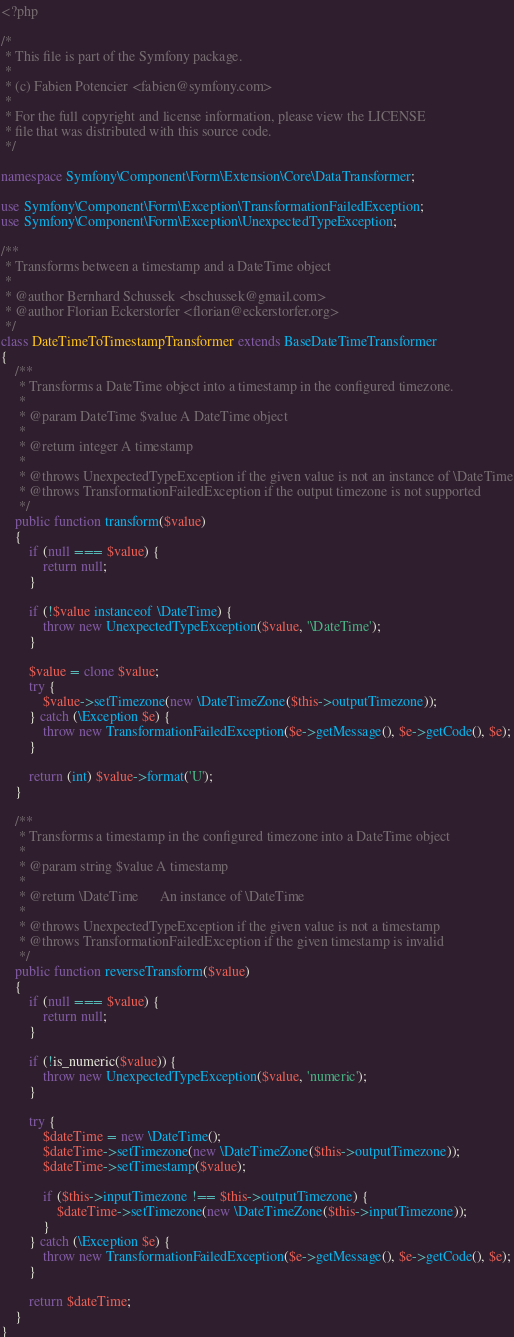Convert code to text. <code><loc_0><loc_0><loc_500><loc_500><_PHP_><?php

/*
 * This file is part of the Symfony package.
 *
 * (c) Fabien Potencier <fabien@symfony.com>
 *
 * For the full copyright and license information, please view the LICENSE
 * file that was distributed with this source code.
 */

namespace Symfony\Component\Form\Extension\Core\DataTransformer;

use Symfony\Component\Form\Exception\TransformationFailedException;
use Symfony\Component\Form\Exception\UnexpectedTypeException;

/**
 * Transforms between a timestamp and a DateTime object
 *
 * @author Bernhard Schussek <bschussek@gmail.com>
 * @author Florian Eckerstorfer <florian@eckerstorfer.org>
 */
class DateTimeToTimestampTransformer extends BaseDateTimeTransformer
{
    /**
     * Transforms a DateTime object into a timestamp in the configured timezone.
     *
     * @param DateTime $value A DateTime object
     *
     * @return integer A timestamp
     *
     * @throws UnexpectedTypeException if the given value is not an instance of \DateTime
     * @throws TransformationFailedException if the output timezone is not supported
     */
    public function transform($value)
    {
        if (null === $value) {
            return null;
        }

        if (!$value instanceof \DateTime) {
            throw new UnexpectedTypeException($value, '\DateTime');
        }

        $value = clone $value;
        try {
            $value->setTimezone(new \DateTimeZone($this->outputTimezone));
        } catch (\Exception $e) {
            throw new TransformationFailedException($e->getMessage(), $e->getCode(), $e);
        }

        return (int) $value->format('U');
    }

    /**
     * Transforms a timestamp in the configured timezone into a DateTime object
     *
     * @param string $value A timestamp
     *
     * @return \DateTime      An instance of \DateTime
     *
     * @throws UnexpectedTypeException if the given value is not a timestamp
     * @throws TransformationFailedException if the given timestamp is invalid
     */
    public function reverseTransform($value)
    {
        if (null === $value) {
            return null;
        }

        if (!is_numeric($value)) {
            throw new UnexpectedTypeException($value, 'numeric');
        }

        try {
            $dateTime = new \DateTime();
            $dateTime->setTimezone(new \DateTimeZone($this->outputTimezone));
            $dateTime->setTimestamp($value);

            if ($this->inputTimezone !== $this->outputTimezone) {
                $dateTime->setTimezone(new \DateTimeZone($this->inputTimezone));
            }
        } catch (\Exception $e) {
            throw new TransformationFailedException($e->getMessage(), $e->getCode(), $e);
        }

        return $dateTime;
    }
}
</code> 